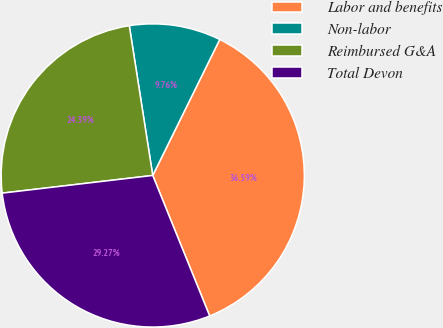Convert chart. <chart><loc_0><loc_0><loc_500><loc_500><pie_chart><fcel>Labor and benefits<fcel>Non-labor<fcel>Reimbursed G&A<fcel>Total Devon<nl><fcel>36.59%<fcel>9.76%<fcel>24.39%<fcel>29.27%<nl></chart> 